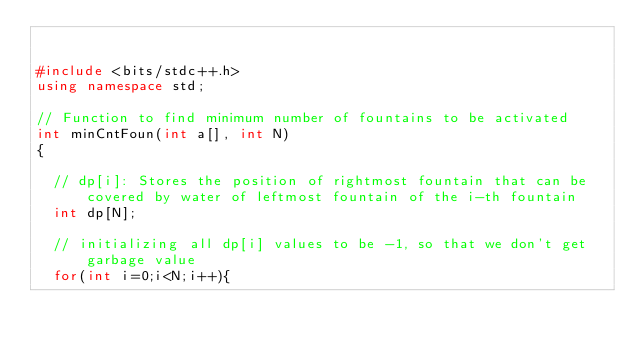Convert code to text. <code><loc_0><loc_0><loc_500><loc_500><_C++_>

#include <bits/stdc++.h>
using namespace std;

// Function to find minimum number of fountains to be activated
int minCntFoun(int a[], int N)
{

	// dp[i]: Stores the position of rightmost fountain that can be covered by water of leftmost fountain of the i-th fountain
	int dp[N];
	
	// initializing all dp[i] values to be -1, so that we don't get garbage value
	for(int i=0;i<N;i++){</code> 